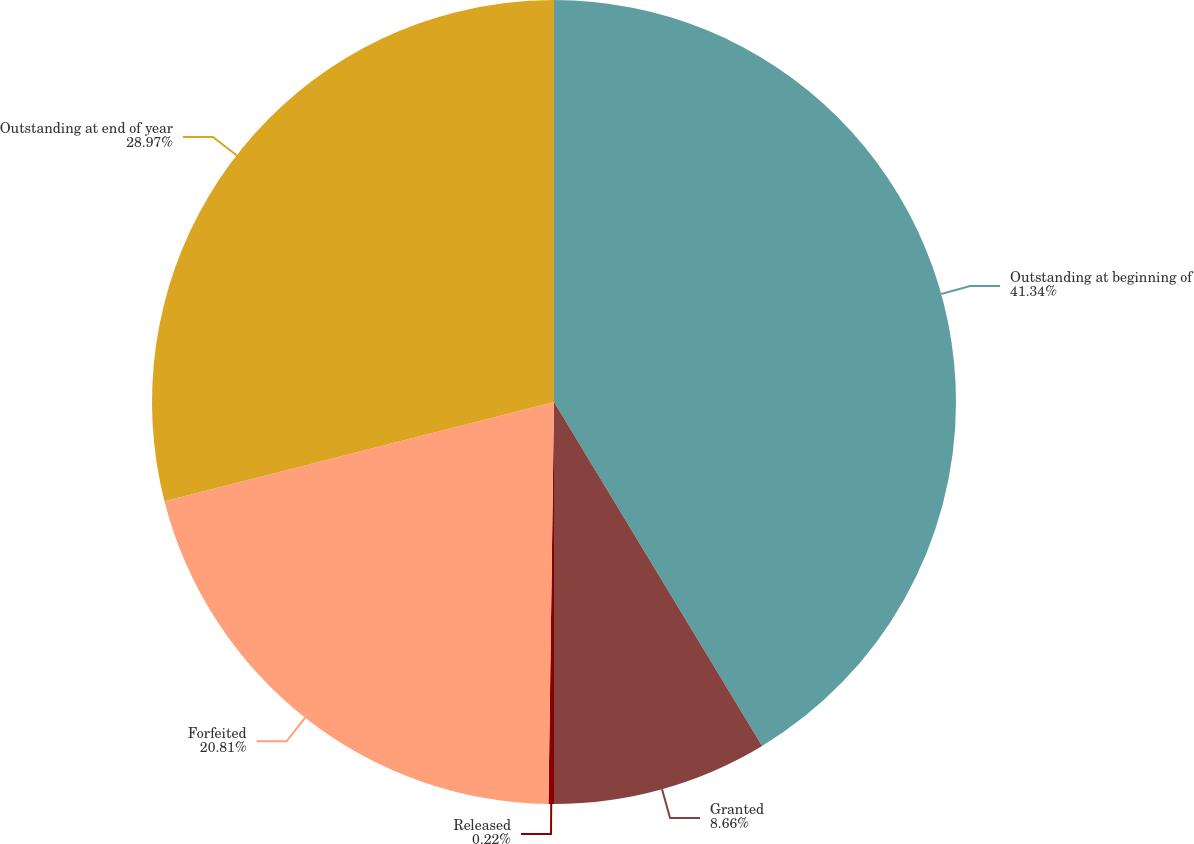Convert chart. <chart><loc_0><loc_0><loc_500><loc_500><pie_chart><fcel>Outstanding at beginning of<fcel>Granted<fcel>Released<fcel>Forfeited<fcel>Outstanding at end of year<nl><fcel>41.34%<fcel>8.66%<fcel>0.22%<fcel>20.81%<fcel>28.97%<nl></chart> 